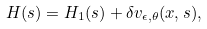<formula> <loc_0><loc_0><loc_500><loc_500>H ( s ) = H _ { 1 } ( s ) + \delta v _ { \epsilon , \theta } ( x , s ) ,</formula> 